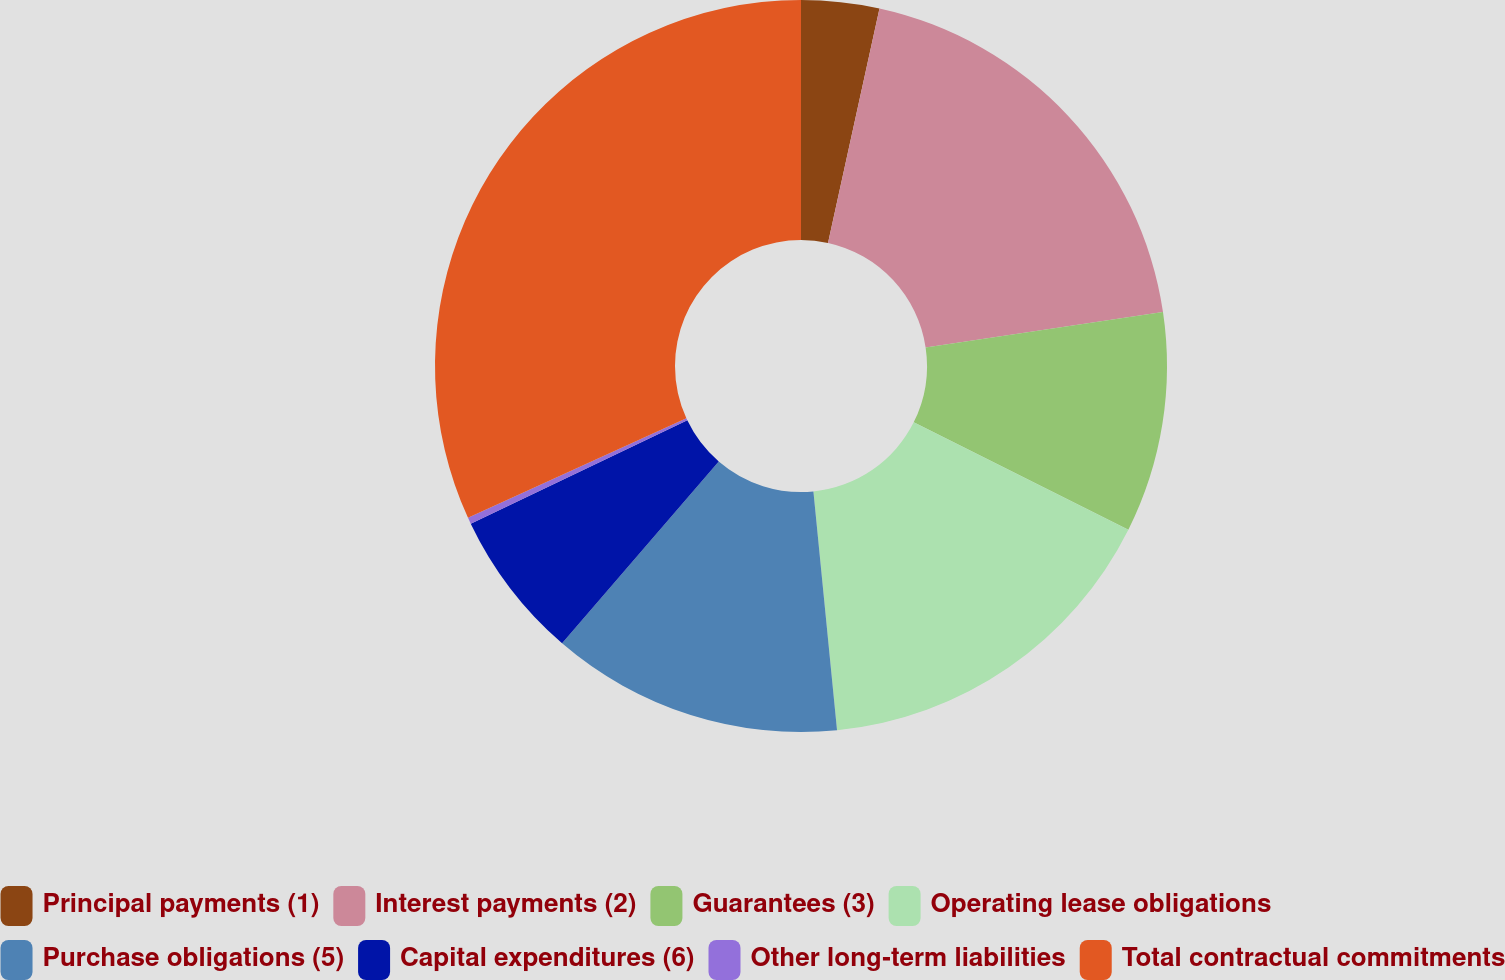Convert chart to OTSL. <chart><loc_0><loc_0><loc_500><loc_500><pie_chart><fcel>Principal payments (1)<fcel>Interest payments (2)<fcel>Guarantees (3)<fcel>Operating lease obligations<fcel>Purchase obligations (5)<fcel>Capital expenditures (6)<fcel>Other long-term liabilities<fcel>Total contractual commitments<nl><fcel>3.44%<fcel>19.2%<fcel>9.74%<fcel>16.05%<fcel>12.89%<fcel>6.59%<fcel>0.28%<fcel>31.81%<nl></chart> 